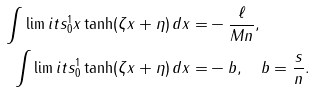<formula> <loc_0><loc_0><loc_500><loc_500>\int \lim i t s _ { 0 } ^ { 1 } x \tanh ( \zeta x + \eta ) \, d x = & - \frac { \ell } { M n } , \\ \int \lim i t s _ { 0 } ^ { 1 } \tanh ( \zeta x + \eta ) \, d x = & - b , \quad b = \frac { s } { n } .</formula> 